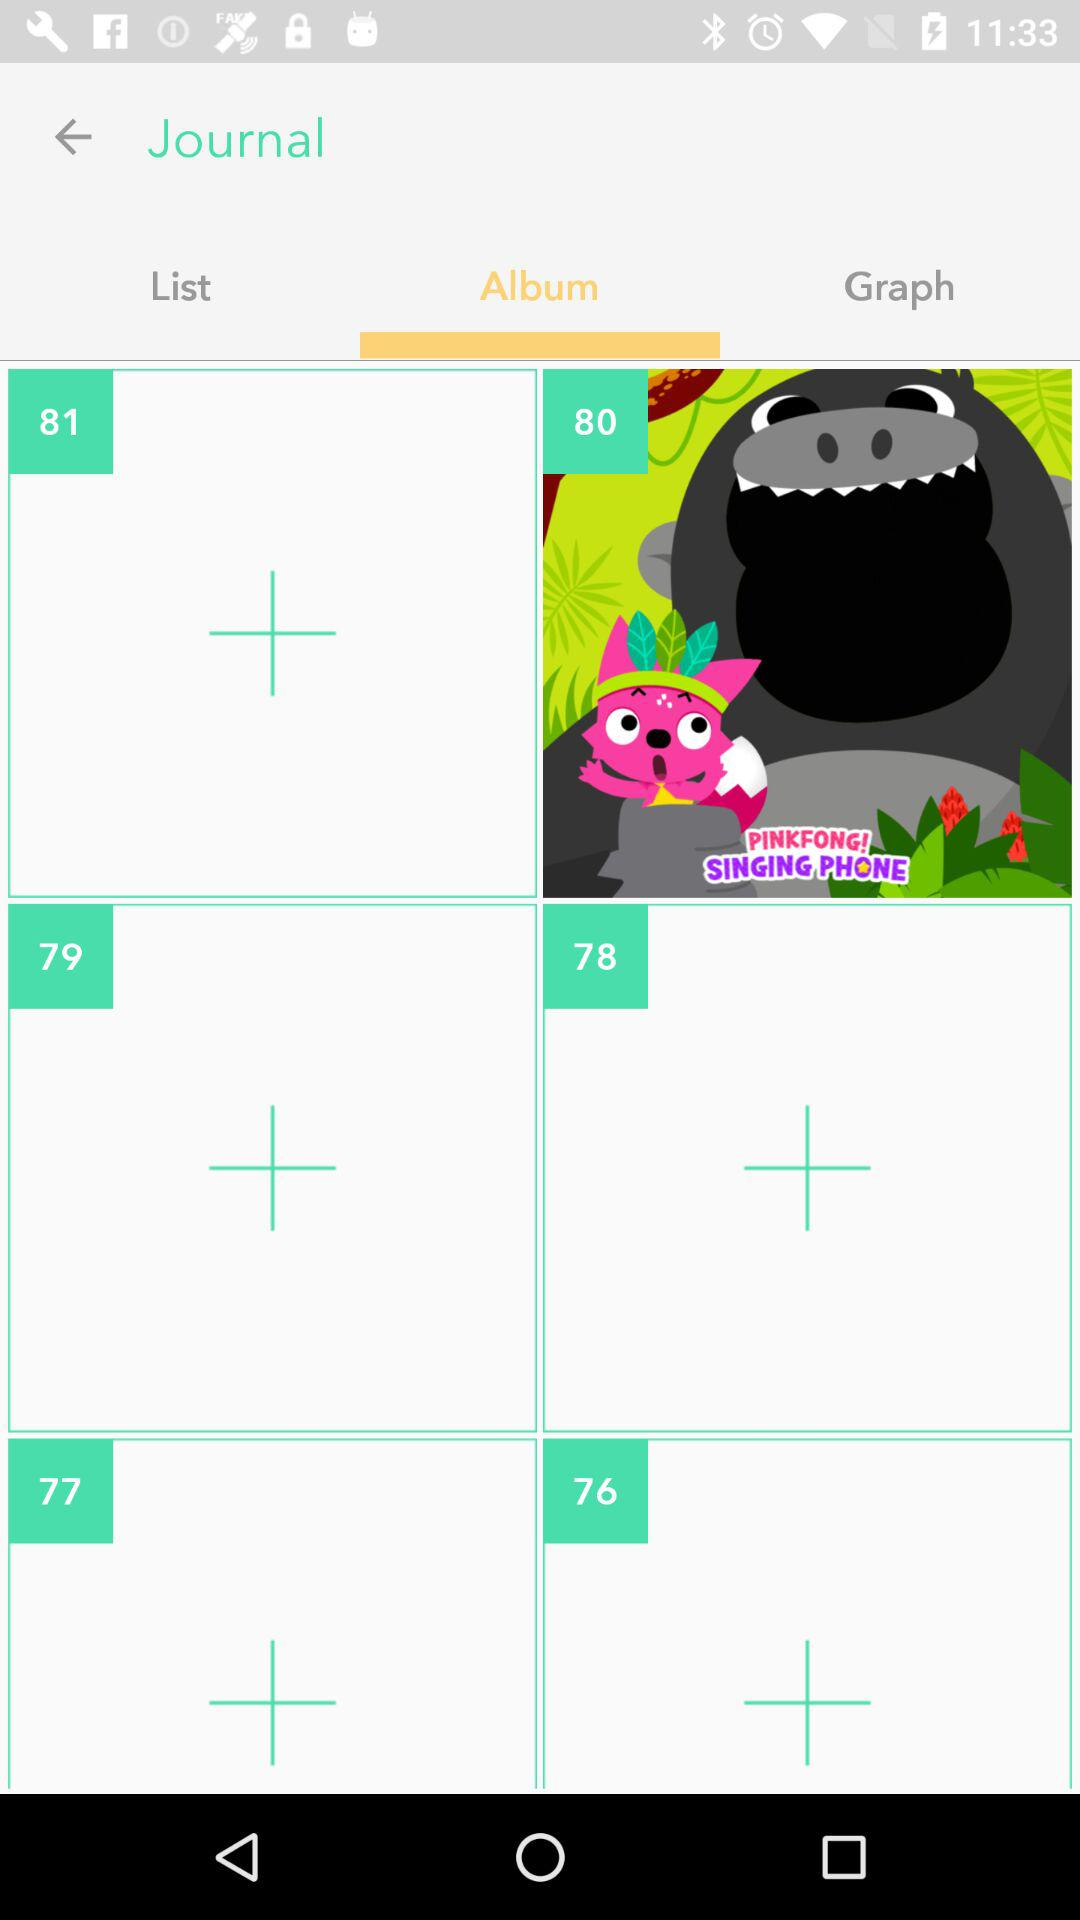What is the selected tab? The selected tab is "Album". 